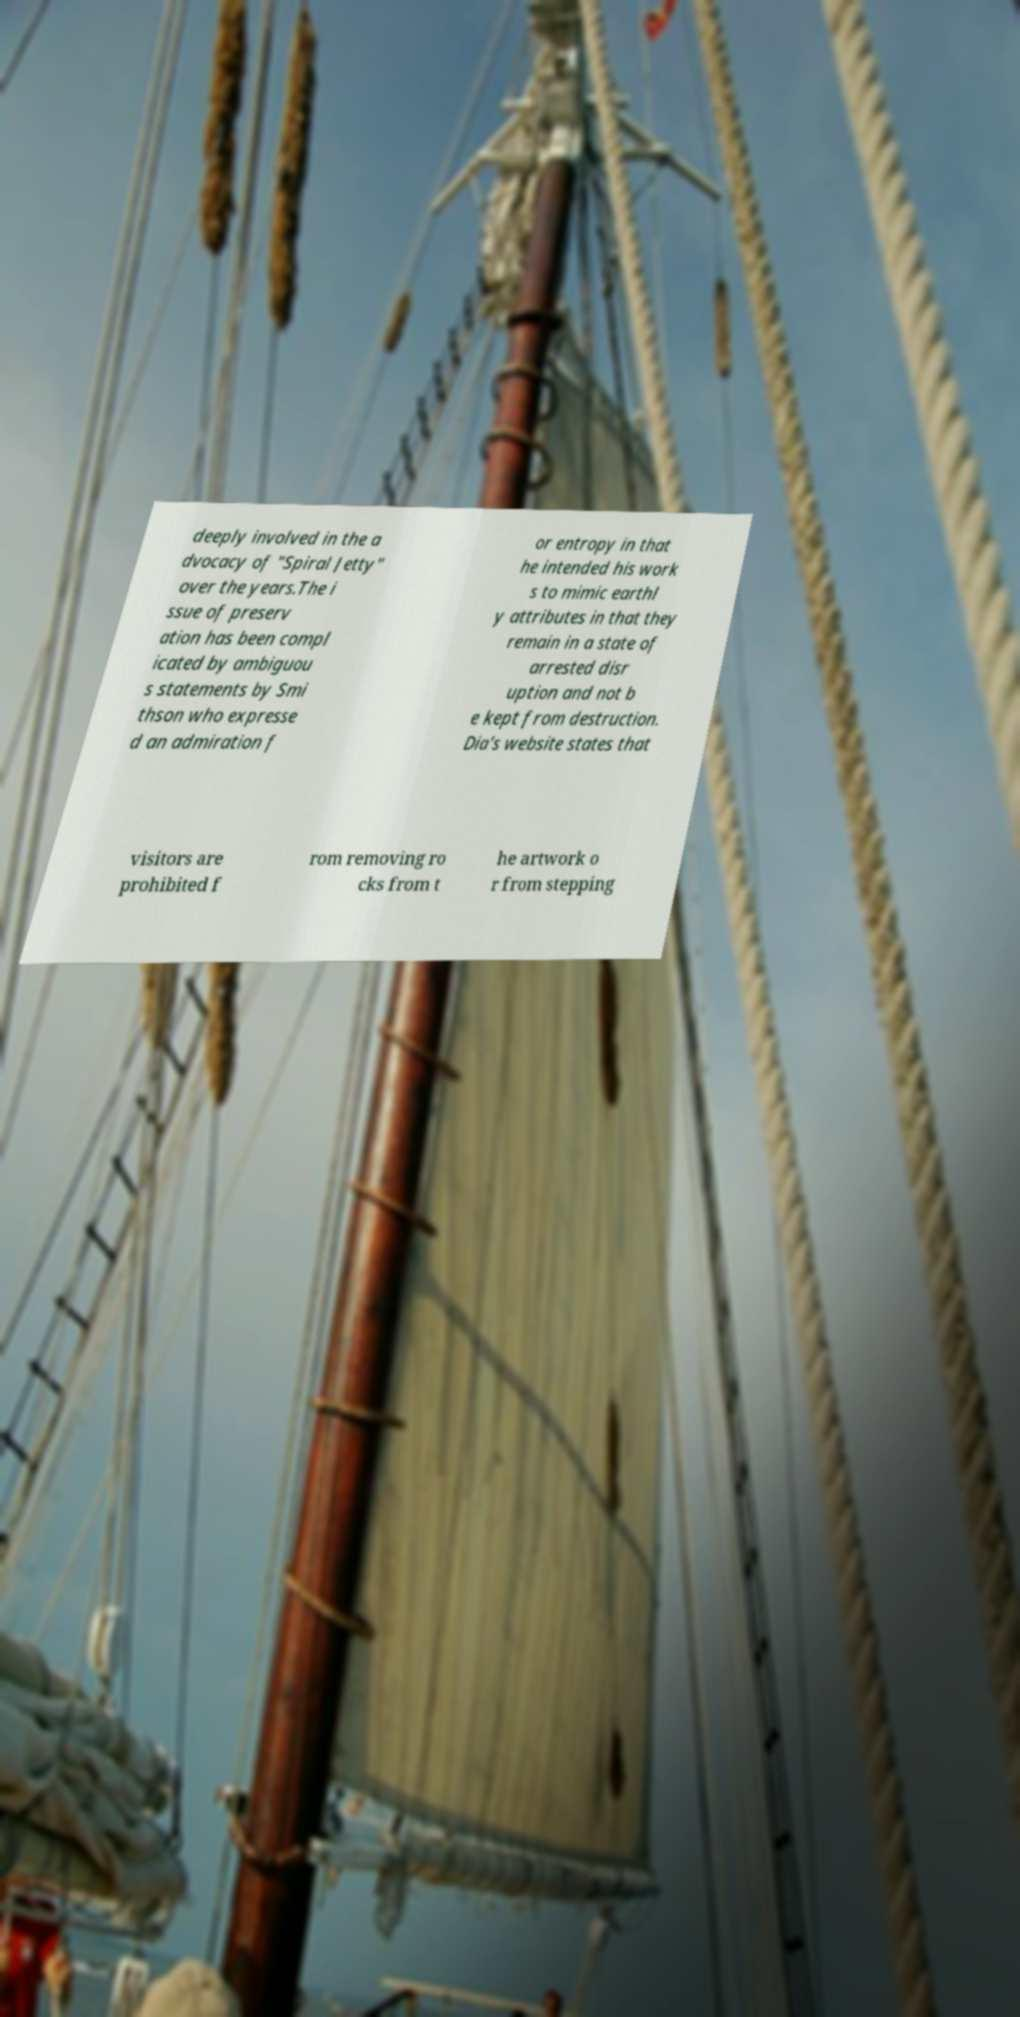Could you assist in decoding the text presented in this image and type it out clearly? deeply involved in the a dvocacy of "Spiral Jetty" over the years.The i ssue of preserv ation has been compl icated by ambiguou s statements by Smi thson who expresse d an admiration f or entropy in that he intended his work s to mimic earthl y attributes in that they remain in a state of arrested disr uption and not b e kept from destruction. Dia's website states that visitors are prohibited f rom removing ro cks from t he artwork o r from stepping 